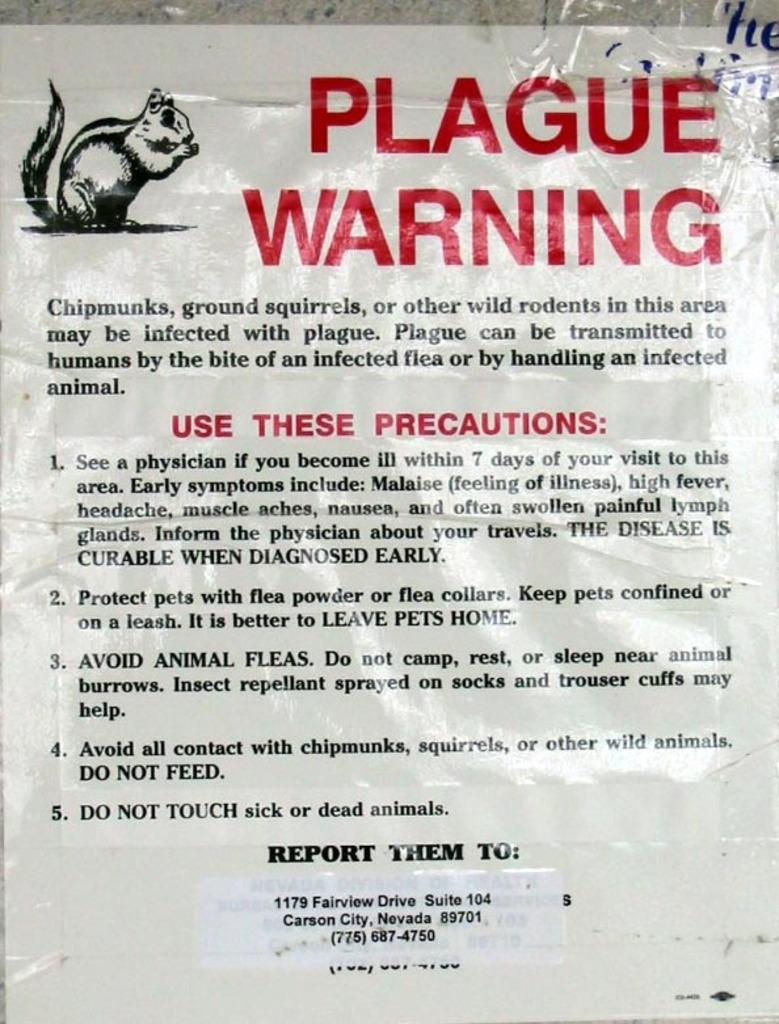What is featured in the image? There is a poster in the image. What can be found on the poster? There is text on the poster. Is there any image on the poster? Yes, there is a squirrel image in the top left corner of the poster. What type of theory is being discussed in the town depicted in the image? There is no town depicted in the image, and therefore no theory being discussed. 